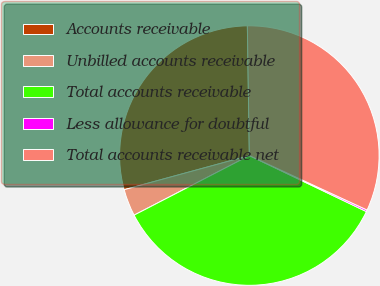Convert chart. <chart><loc_0><loc_0><loc_500><loc_500><pie_chart><fcel>Accounts receivable<fcel>Unbilled accounts receivable<fcel>Total accounts receivable<fcel>Less allowance for doubtful<fcel>Total accounts receivable net<nl><fcel>28.99%<fcel>3.36%<fcel>35.3%<fcel>0.21%<fcel>32.14%<nl></chart> 